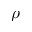<formula> <loc_0><loc_0><loc_500><loc_500>\rho</formula> 